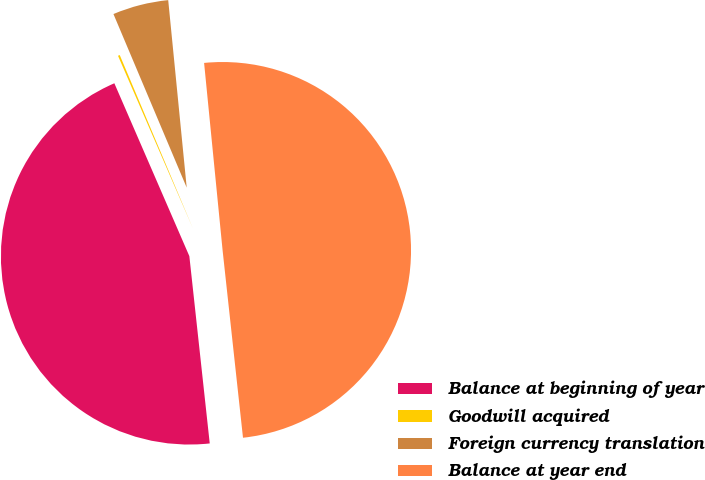<chart> <loc_0><loc_0><loc_500><loc_500><pie_chart><fcel>Balance at beginning of year<fcel>Goodwill acquired<fcel>Foreign currency translation<fcel>Balance at year end<nl><fcel>45.21%<fcel>0.16%<fcel>4.79%<fcel>49.84%<nl></chart> 